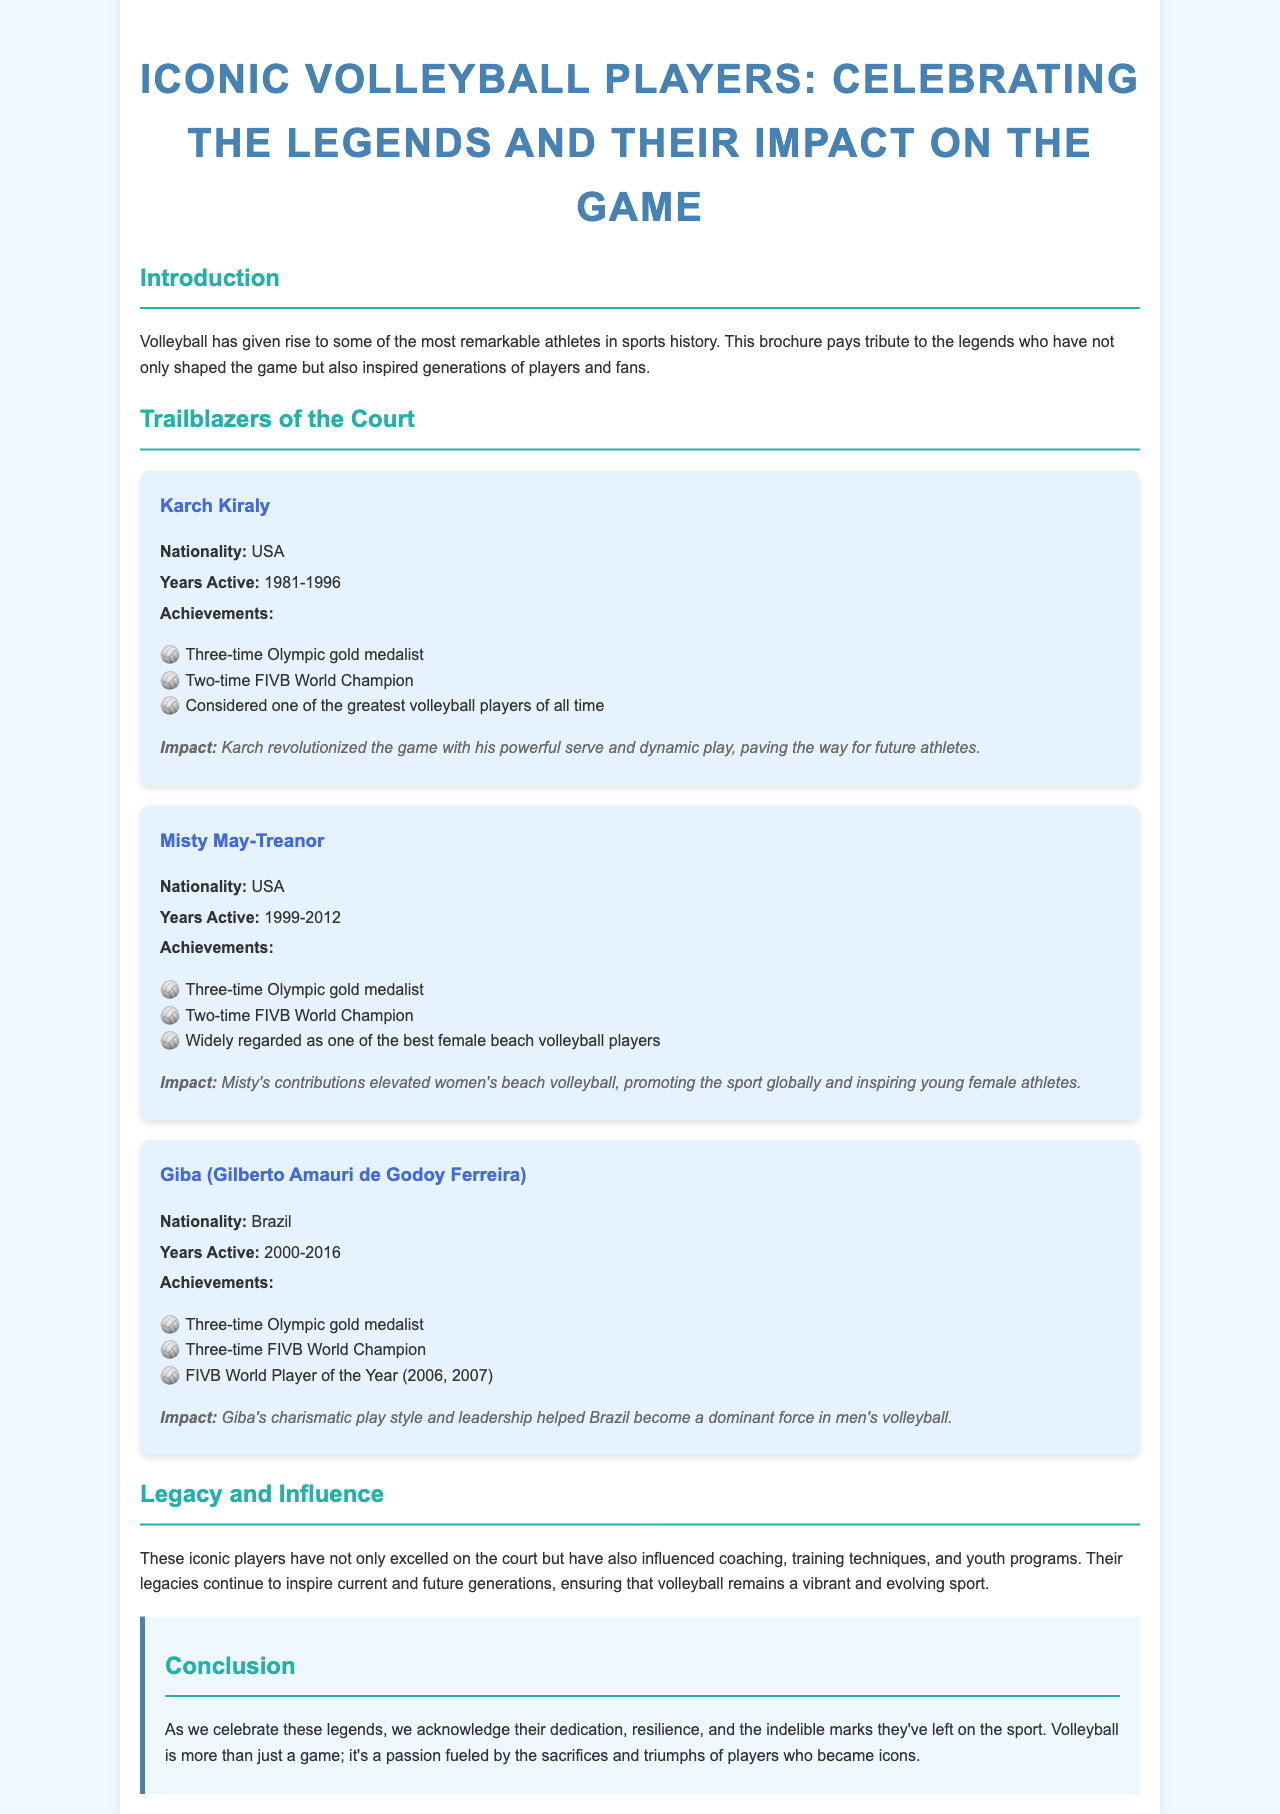What is the title of the brochure? The title provides the main focus of the document, which is about iconic volleyball players and celebrates their contributions to the sport.
Answer: Iconic Volleyball Players: Celebrating the Legends and Their Impact on the Game Who is regarded as one of the greatest volleyball players of all time? This refers to Karch Kiraly, whose achievements are highlighted in the document.
Answer: Karch Kiraly How many Olympic gold medals did Misty May-Treanor win? The document states that Misty May-Treanor won three Olympic gold medals as part of her achievements.
Answer: Three What nationality is Giba? The document specifies Giba's nationality under his profile, which is relevant for understanding his background.
Answer: Brazil During which years was Karch Kiraly active? This question looks for the specific time frame during which Karch Kiraly performed at a professional level.
Answer: 1981-1996 What impact did Misty May-Treanor have on women's beach volleyball? The document describes her contributions, showing her influence on the sport's popularity and development.
Answer: Promoting the sport globally and inspiring young female athletes Which section discusses the legacy of iconic players? The document presents various sections, and this question targets the one focusing on the lasting influence of the highlighted athletes.
Answer: Legacy and Influence What sport does this brochure focus on? This question seeks to clarify the subject matter discussed throughout the brochure.
Answer: Volleyball 